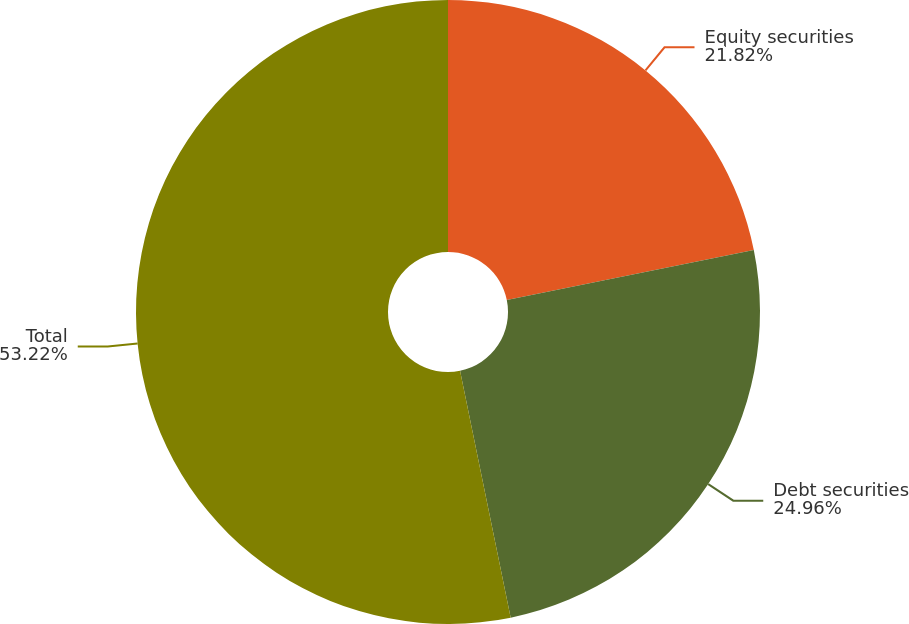<chart> <loc_0><loc_0><loc_500><loc_500><pie_chart><fcel>Equity securities<fcel>Debt securities<fcel>Total<nl><fcel>21.82%<fcel>24.96%<fcel>53.22%<nl></chart> 